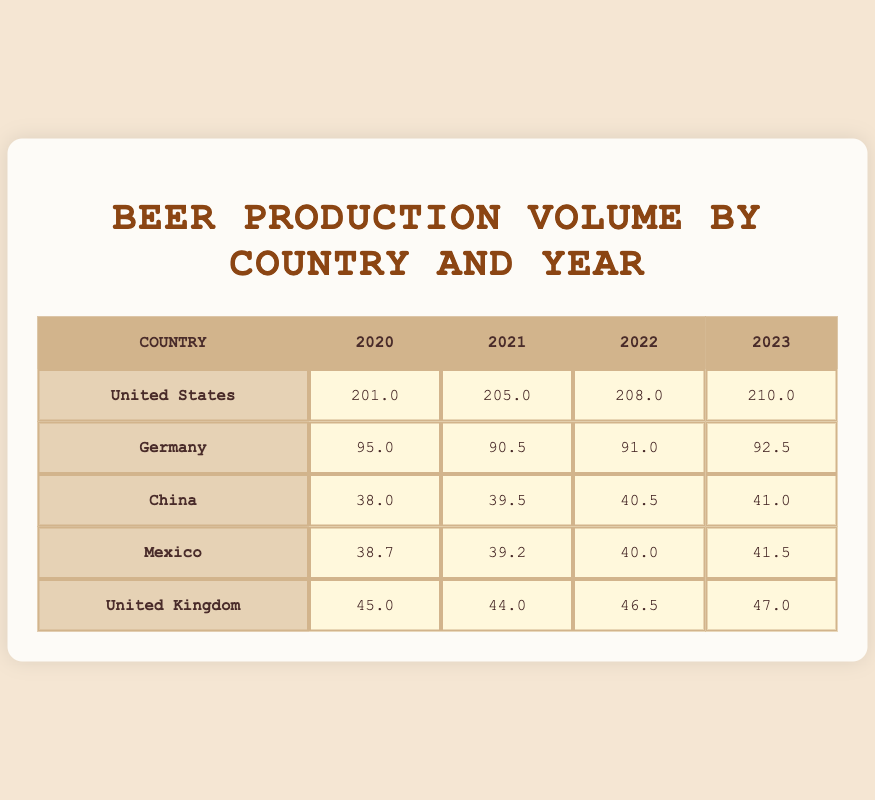What was the beer production volume in Germany in 2023? From the table, the row for Germany under the 2023 column shows a production volume of 92.5 million liters.
Answer: 92.5 million liters Which country had the highest beer production volume in 2022? In the table, the United States has the highest production volume with 208.0 million liters for the year 2022, as this value is greater than Germany’s 91.0 million liters, China’s 40.5 million liters, Mexico’s 40.0 million liters, and the United Kingdom’s 46.5 million liters.
Answer: United States What is the total beer production volume in Mexico from 2020 to 2023? To find the total production volume, we add the volumes for Mexico: 38.7 (2020) + 39.2 (2021) + 40.0 (2022) + 41.5 (2023) = 159.4 million liters.
Answer: 159.4 million liters Did China’s beer production volume increase every year from 2020 to 2023? By examining the table, China’s production volumes for each year are 38.0 (2020), 39.5 (2021), 40.5 (2022), and 41.0 (2023), which shows an increase each year, confirming that it did increase every year.
Answer: Yes What is the difference in beer production volume for the United Kingdom between 2020 and 2023? The volume in 2020 is 45.0 million liters, and in 2023, it is 47.0 million liters. The difference is calculated as 47.0 - 45.0 = 2.0 million liters.
Answer: 2.0 million liters What was the average beer production volume across all countries in 2021? From the table, the production volumes for 2021 are: United States (205.0), Germany (90.5), China (39.5), Mexico (39.2), United Kingdom (44.0). The sum is 205.0 + 90.5 + 39.5 + 39.2 + 44.0 = 418.2 million liters. There are 5 countries, so the average is 418.2 / 5 = 83.64 million liters.
Answer: 83.64 million liters Which country showed the smallest production volume in 2022? In 2022, the table indicates the volumes: United States (208.0), Germany (91.0), China (40.5), Mexico (40.0), United Kingdom (46.5). The smallest production volume is 40.0 million liters from Mexico.
Answer: Mexico Was there a decrease in beer production volume in Germany from 2020 to 2021? Looking at the table, Germany produced 95.0 million liters in 2020 and produced 90.5 million liters in 2021. Since 90.5 is less than 95.0, it indicates a decrease.
Answer: Yes 